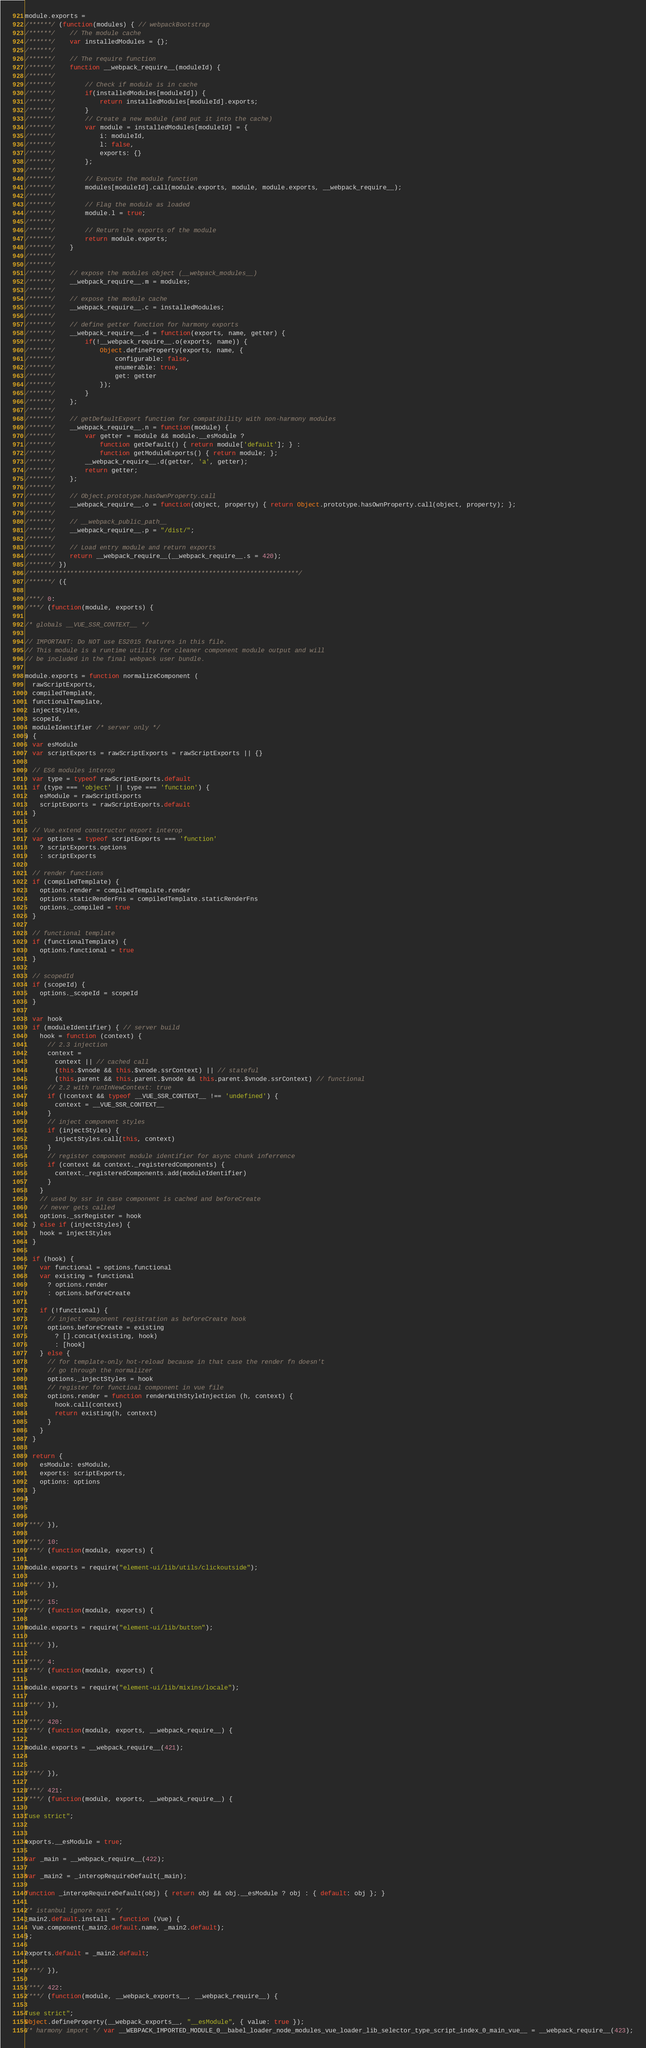<code> <loc_0><loc_0><loc_500><loc_500><_JavaScript_>module.exports =
/******/ (function(modules) { // webpackBootstrap
/******/ 	// The module cache
/******/ 	var installedModules = {};
/******/
/******/ 	// The require function
/******/ 	function __webpack_require__(moduleId) {
/******/
/******/ 		// Check if module is in cache
/******/ 		if(installedModules[moduleId]) {
/******/ 			return installedModules[moduleId].exports;
/******/ 		}
/******/ 		// Create a new module (and put it into the cache)
/******/ 		var module = installedModules[moduleId] = {
/******/ 			i: moduleId,
/******/ 			l: false,
/******/ 			exports: {}
/******/ 		};
/******/
/******/ 		// Execute the module function
/******/ 		modules[moduleId].call(module.exports, module, module.exports, __webpack_require__);
/******/
/******/ 		// Flag the module as loaded
/******/ 		module.l = true;
/******/
/******/ 		// Return the exports of the module
/******/ 		return module.exports;
/******/ 	}
/******/
/******/
/******/ 	// expose the modules object (__webpack_modules__)
/******/ 	__webpack_require__.m = modules;
/******/
/******/ 	// expose the module cache
/******/ 	__webpack_require__.c = installedModules;
/******/
/******/ 	// define getter function for harmony exports
/******/ 	__webpack_require__.d = function(exports, name, getter) {
/******/ 		if(!__webpack_require__.o(exports, name)) {
/******/ 			Object.defineProperty(exports, name, {
/******/ 				configurable: false,
/******/ 				enumerable: true,
/******/ 				get: getter
/******/ 			});
/******/ 		}
/******/ 	};
/******/
/******/ 	// getDefaultExport function for compatibility with non-harmony modules
/******/ 	__webpack_require__.n = function(module) {
/******/ 		var getter = module && module.__esModule ?
/******/ 			function getDefault() { return module['default']; } :
/******/ 			function getModuleExports() { return module; };
/******/ 		__webpack_require__.d(getter, 'a', getter);
/******/ 		return getter;
/******/ 	};
/******/
/******/ 	// Object.prototype.hasOwnProperty.call
/******/ 	__webpack_require__.o = function(object, property) { return Object.prototype.hasOwnProperty.call(object, property); };
/******/
/******/ 	// __webpack_public_path__
/******/ 	__webpack_require__.p = "/dist/";
/******/
/******/ 	// Load entry module and return exports
/******/ 	return __webpack_require__(__webpack_require__.s = 420);
/******/ })
/************************************************************************/
/******/ ({

/***/ 0:
/***/ (function(module, exports) {

/* globals __VUE_SSR_CONTEXT__ */

// IMPORTANT: Do NOT use ES2015 features in this file.
// This module is a runtime utility for cleaner component module output and will
// be included in the final webpack user bundle.

module.exports = function normalizeComponent (
  rawScriptExports,
  compiledTemplate,
  functionalTemplate,
  injectStyles,
  scopeId,
  moduleIdentifier /* server only */
) {
  var esModule
  var scriptExports = rawScriptExports = rawScriptExports || {}

  // ES6 modules interop
  var type = typeof rawScriptExports.default
  if (type === 'object' || type === 'function') {
    esModule = rawScriptExports
    scriptExports = rawScriptExports.default
  }

  // Vue.extend constructor export interop
  var options = typeof scriptExports === 'function'
    ? scriptExports.options
    : scriptExports

  // render functions
  if (compiledTemplate) {
    options.render = compiledTemplate.render
    options.staticRenderFns = compiledTemplate.staticRenderFns
    options._compiled = true
  }

  // functional template
  if (functionalTemplate) {
    options.functional = true
  }

  // scopedId
  if (scopeId) {
    options._scopeId = scopeId
  }

  var hook
  if (moduleIdentifier) { // server build
    hook = function (context) {
      // 2.3 injection
      context =
        context || // cached call
        (this.$vnode && this.$vnode.ssrContext) || // stateful
        (this.parent && this.parent.$vnode && this.parent.$vnode.ssrContext) // functional
      // 2.2 with runInNewContext: true
      if (!context && typeof __VUE_SSR_CONTEXT__ !== 'undefined') {
        context = __VUE_SSR_CONTEXT__
      }
      // inject component styles
      if (injectStyles) {
        injectStyles.call(this, context)
      }
      // register component module identifier for async chunk inferrence
      if (context && context._registeredComponents) {
        context._registeredComponents.add(moduleIdentifier)
      }
    }
    // used by ssr in case component is cached and beforeCreate
    // never gets called
    options._ssrRegister = hook
  } else if (injectStyles) {
    hook = injectStyles
  }

  if (hook) {
    var functional = options.functional
    var existing = functional
      ? options.render
      : options.beforeCreate

    if (!functional) {
      // inject component registration as beforeCreate hook
      options.beforeCreate = existing
        ? [].concat(existing, hook)
        : [hook]
    } else {
      // for template-only hot-reload because in that case the render fn doesn't
      // go through the normalizer
      options._injectStyles = hook
      // register for functioal component in vue file
      options.render = function renderWithStyleInjection (h, context) {
        hook.call(context)
        return existing(h, context)
      }
    }
  }

  return {
    esModule: esModule,
    exports: scriptExports,
    options: options
  }
}


/***/ }),

/***/ 10:
/***/ (function(module, exports) {

module.exports = require("element-ui/lib/utils/clickoutside");

/***/ }),

/***/ 15:
/***/ (function(module, exports) {

module.exports = require("element-ui/lib/button");

/***/ }),

/***/ 4:
/***/ (function(module, exports) {

module.exports = require("element-ui/lib/mixins/locale");

/***/ }),

/***/ 420:
/***/ (function(module, exports, __webpack_require__) {

module.exports = __webpack_require__(421);


/***/ }),

/***/ 421:
/***/ (function(module, exports, __webpack_require__) {

"use strict";


exports.__esModule = true;

var _main = __webpack_require__(422);

var _main2 = _interopRequireDefault(_main);

function _interopRequireDefault(obj) { return obj && obj.__esModule ? obj : { default: obj }; }

/* istanbul ignore next */
_main2.default.install = function (Vue) {
  Vue.component(_main2.default.name, _main2.default);
};

exports.default = _main2.default;

/***/ }),

/***/ 422:
/***/ (function(module, __webpack_exports__, __webpack_require__) {

"use strict";
Object.defineProperty(__webpack_exports__, "__esModule", { value: true });
/* harmony import */ var __WEBPACK_IMPORTED_MODULE_0__babel_loader_node_modules_vue_loader_lib_selector_type_script_index_0_main_vue__ = __webpack_require__(423);</code> 